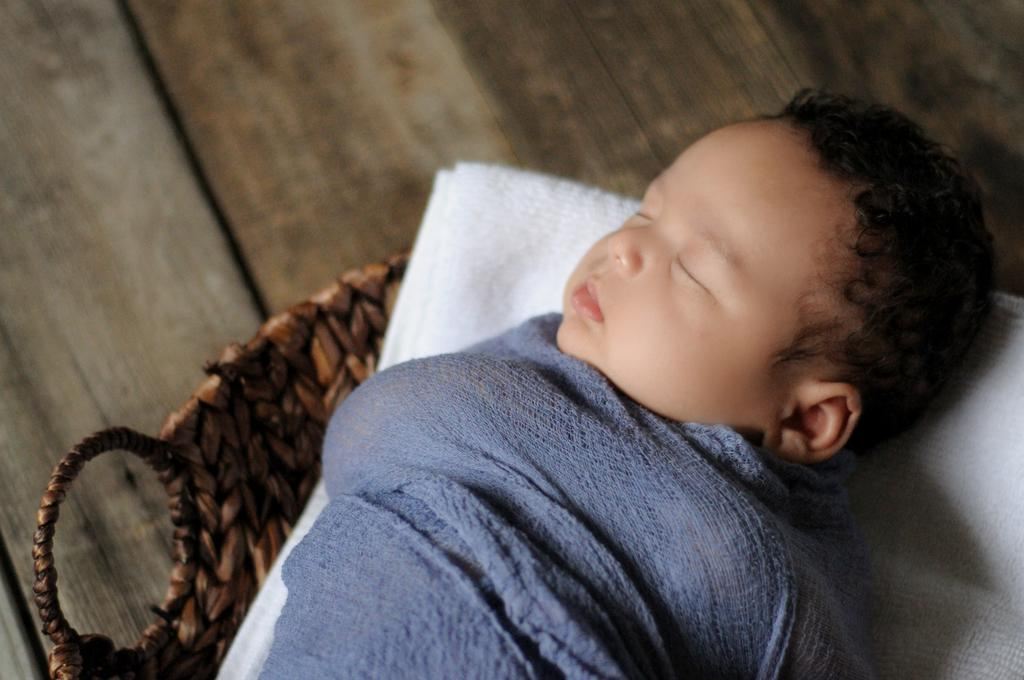What is the main subject of the image? The main subject of the image is a baby. What is the baby doing in the image? The baby is sleeping. What is the baby lying on in the image? The baby is on a cloth. What color is the cloth that the baby is lying on? The cloth is white in color. Where is the cloth located in the image? The cloth is in a basket. What is the chance of the baby hitting a home run in the image? There is no reference to a baseball game or a home run in the image, so it's not possible to determine the chance of the baby hitting a home run. 